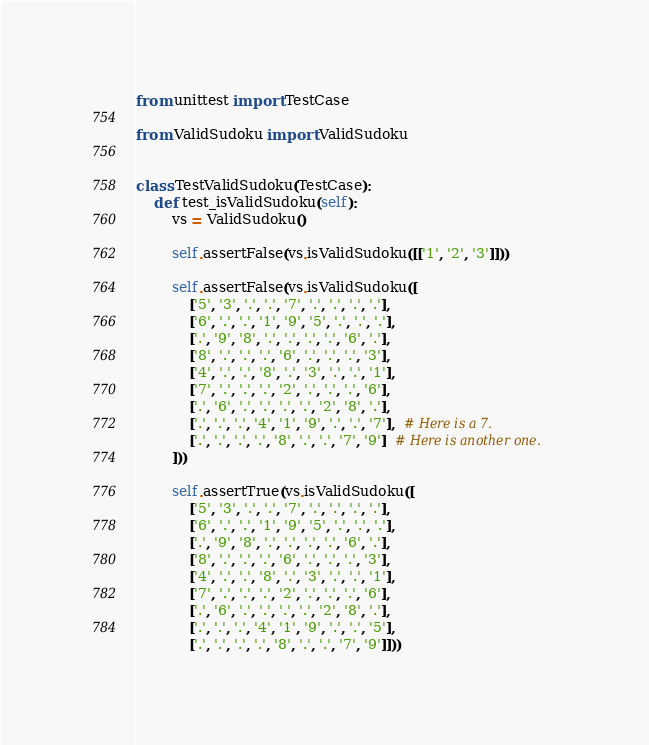Convert code to text. <code><loc_0><loc_0><loc_500><loc_500><_Python_>from unittest import TestCase

from ValidSudoku import ValidSudoku


class TestValidSudoku(TestCase):
    def test_isValidSudoku(self):
        vs = ValidSudoku()

        self.assertFalse(vs.isValidSudoku([['1', '2', '3']]))

        self.assertFalse(vs.isValidSudoku([
            ['5', '3', '.', '.', '7', '.', '.', '.', '.'],
            ['6', '.', '.', '1', '9', '5', '.', '.', '.'],
            ['.', '9', '8', '.', '.', '.', '.', '6', '.'],
            ['8', '.', '.', '.', '6', '.', '.', '.', '3'],
            ['4', '.', '.', '8', '.', '3', '.', '.', '1'],
            ['7', '.', '.', '.', '2', '.', '.', '.', '6'],
            ['.', '6', '.', '.', '.', '.', '2', '8', '.'],
            ['.', '.', '.', '4', '1', '9', '.', '.', '7'],  # Here is a 7.
            ['.', '.', '.', '.', '8', '.', '.', '7', '9']  # Here is another one.
        ]))

        self.assertTrue(vs.isValidSudoku([
            ['5', '3', '.', '.', '7', '.', '.', '.', '.'],
            ['6', '.', '.', '1', '9', '5', '.', '.', '.'],
            ['.', '9', '8', '.', '.', '.', '.', '6', '.'],
            ['8', '.', '.', '.', '6', '.', '.', '.', '3'],
            ['4', '.', '.', '8', '.', '3', '.', '.', '1'],
            ['7', '.', '.', '.', '2', '.', '.', '.', '6'],
            ['.', '6', '.', '.', '.', '.', '2', '8', '.'],
            ['.', '.', '.', '4', '1', '9', '.', '.', '5'],
            ['.', '.', '.', '.', '8', '.', '.', '7', '9']]))
</code> 